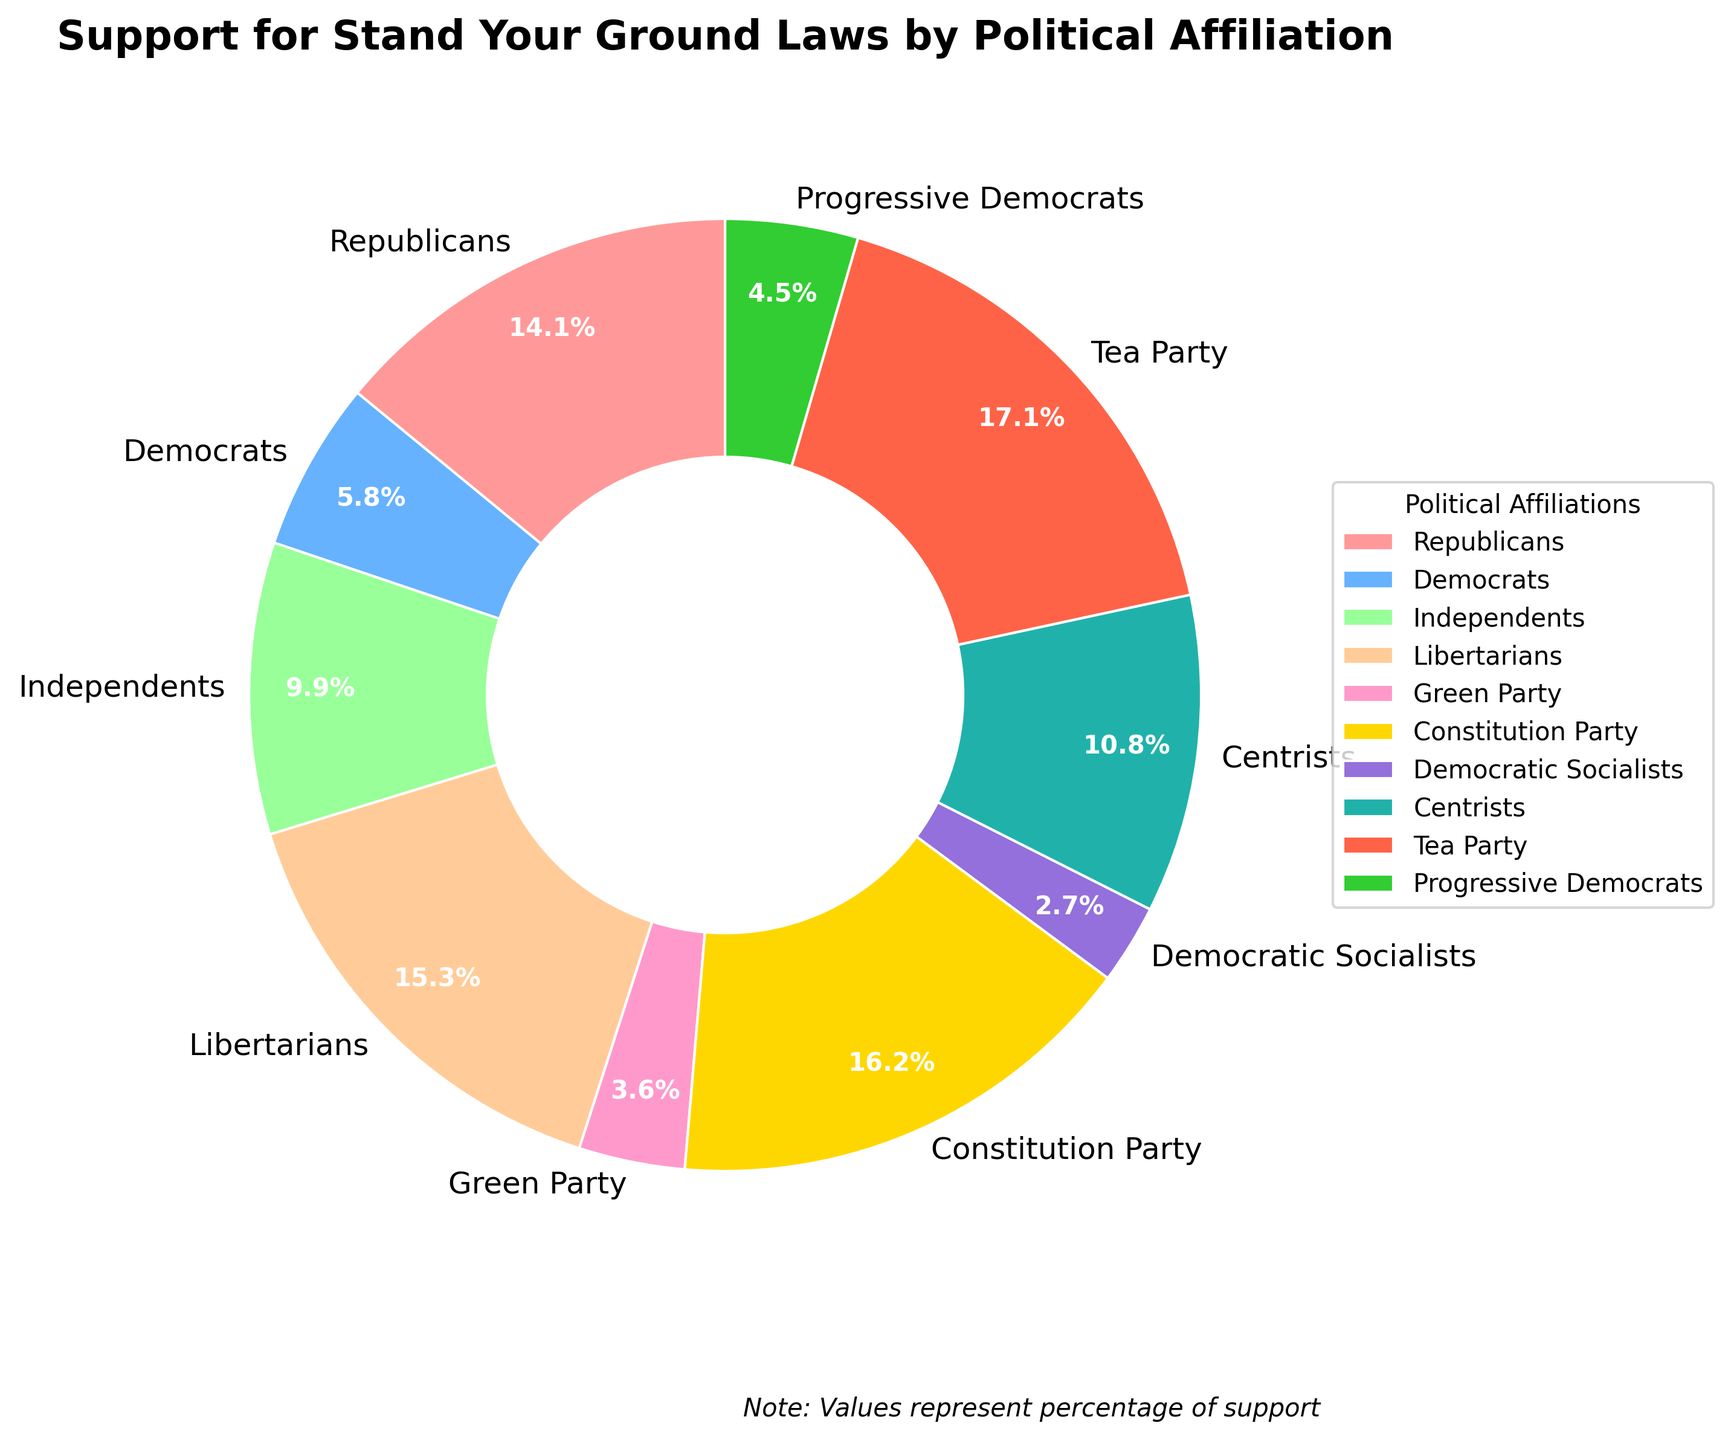Which political affiliation shows the highest support for Stand Your Ground laws? The figure displays the percentage of support for Stand Your Ground laws by each political affiliation. The highest percentage support is observed in the Tea Party segment as represented by the largest wedge in the pie chart.
Answer: Tea Party Which political affiliation has the lowest support for Stand Your Ground laws? Analyzing the pie chart, the smallest wedge corresponds to the Democratic Socialists, indicating they have the lowest percentage of support for Stand Your Ground laws.
Answer: Democratic Socialists How much higher is the support for Stand Your Ground laws among Republicans compared to Democrats? The pie chart shows 78% support among Republicans and 32% support among Democrats. Subtracting these values gives the difference: 78% - 32% = 46%.
Answer: 46% Compare the support for Stand Your Ground laws between Libertarians and Progress  Democrats. Which group has a higher support percentage, and by how much? The pie chart indicates 85% support among Libertarians and 25% support among Progressive Democrats. The difference is calculated by subtracting 25% from 85%, yielding a 60% higher support for the Libertarians.
Answer: Libertarians by 60% Which two political affiliations have support percentages that add up to around 100%? From the pie chart, the support percentages for Independents (55%) and Democrats (32%) add up to 87%. However, the combination of Centrists (60%) and Progress Democrats (25%) comes closer with a total of 85%. None perfectly add to 100%, but these are the closest.
Answer: Independents and Democrats (87%) or Centrists and Progressive Democrats (85%) What is the combined average support for Stand Your Ground laws among Republicans, Libertarians, and Tea Party members? The support percentages from the pie chart are 78% for Republicans, 85% for Libertarians, and 95% for Tea Party members. The average is calculated as follows: (78% + 85% + 95%) / 3 = 86%.
Answer: 86% How does the support for Stand Your Ground laws among Independents compare to that of Centrists? According to the pie chart, Independents show a 55% support while Centrists show a 60% support. This indicates that Centrists have a 5% higher support compared to Independents.
Answer: Centrists by 5% What is the difference in support for Stand Your Ground laws between the Green Party and the Constitutional Party? The pie chart shows that the Green Party has 20% support while the Constitutional Party has 90% support. The difference is calculated by subtracting 20% from 90%, resulting in a 70% difference.
Answer: 70% To which color is the wedge representing Republicans closest in the pie chart? The visual attributes in the pie chart illustrate that the wedge representing Republicans is colored in a distinct hue. In this case, the closest matching color from the custom palette is the reddish-pink section.
Answer: Reddish-pink Which affiliations have support percentages higher than 50%, and which specific percentage do they represent? From analyzing the pie chart, the affiliations with over 50% support are Republicans (78%), Libertarians (85%), Constitution Party (90%), Centrists (60%), and Tea Party (95%). Each of these percentages is visually represented by relatively large wedges in the chart.
Answer: Republicans (78%), Libertarians (85%), Constitution Party (90%), Centrists (60%), Tea Party (95%) 